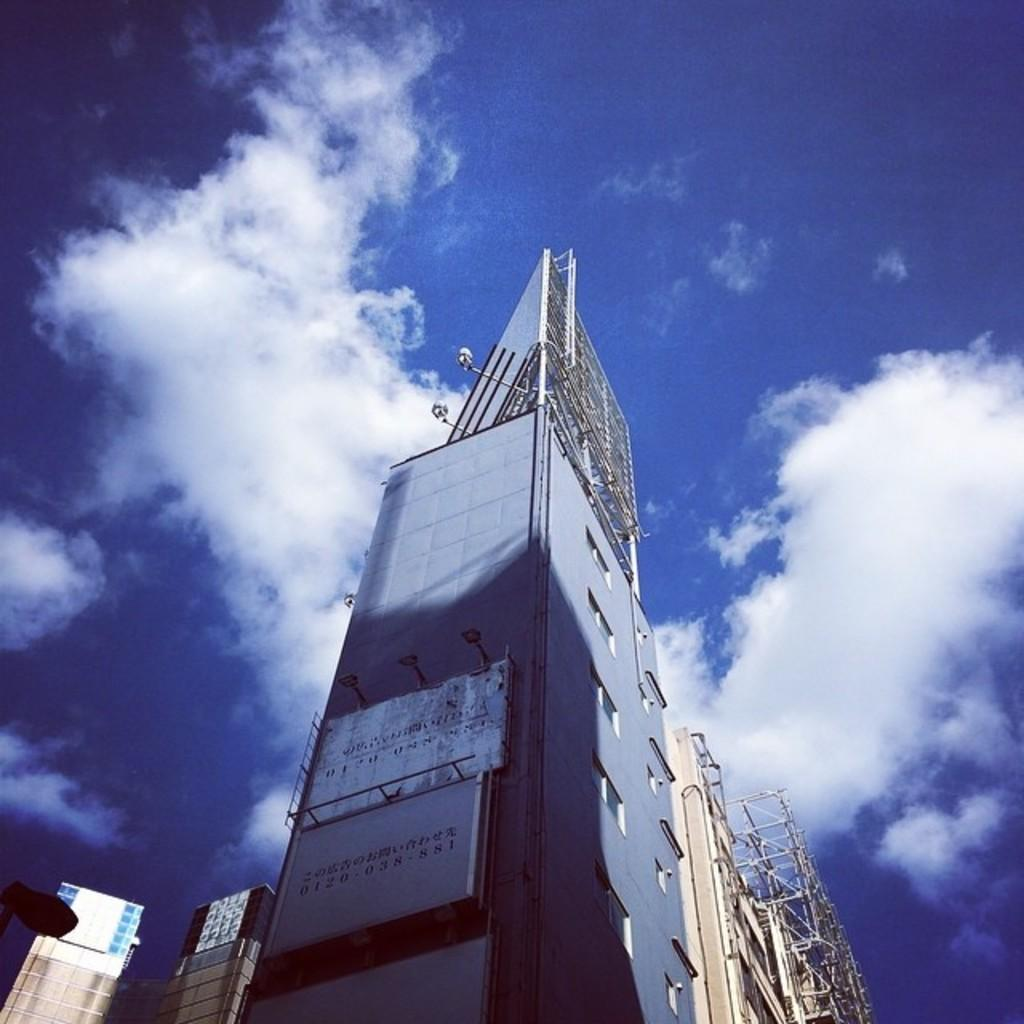What type of structures are present in the image? There are buildings with windows in the image. Can you describe any additional features on the buildings? Yes, there are boards on one of the buildings. What can be seen in the background of the image? There are clouds visible in the background of the image, and the sky is blue. What type of vegetable is being washed in the basin in the image? There is no basin or vegetable present in the image. Can you describe the fingerprints on the windows in the image? There is no mention of fingerprints on the windows in the provided facts, so we cannot answer this question. 